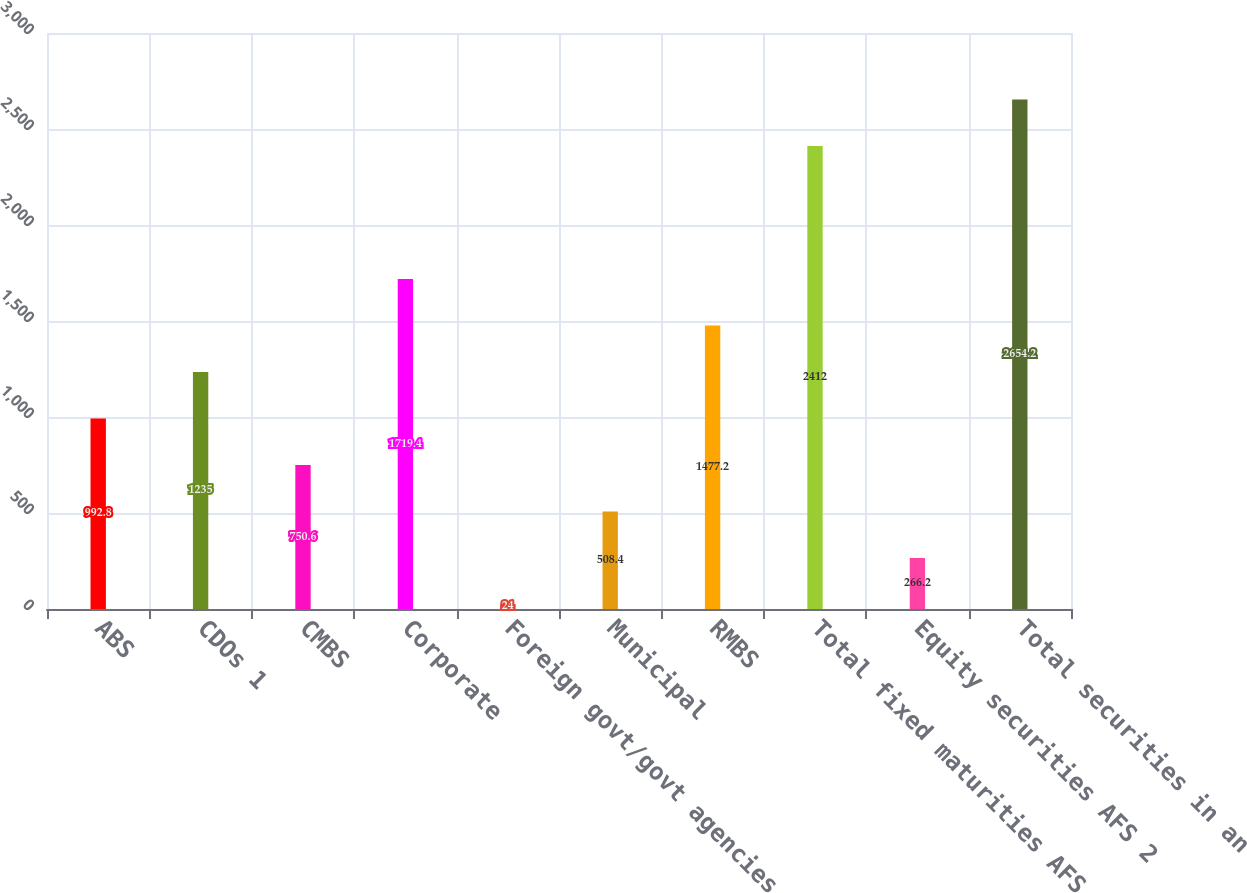Convert chart to OTSL. <chart><loc_0><loc_0><loc_500><loc_500><bar_chart><fcel>ABS<fcel>CDOs 1<fcel>CMBS<fcel>Corporate<fcel>Foreign govt/govt agencies<fcel>Municipal<fcel>RMBS<fcel>Total fixed maturities AFS<fcel>Equity securities AFS 2<fcel>Total securities in an<nl><fcel>992.8<fcel>1235<fcel>750.6<fcel>1719.4<fcel>24<fcel>508.4<fcel>1477.2<fcel>2412<fcel>266.2<fcel>2654.2<nl></chart> 